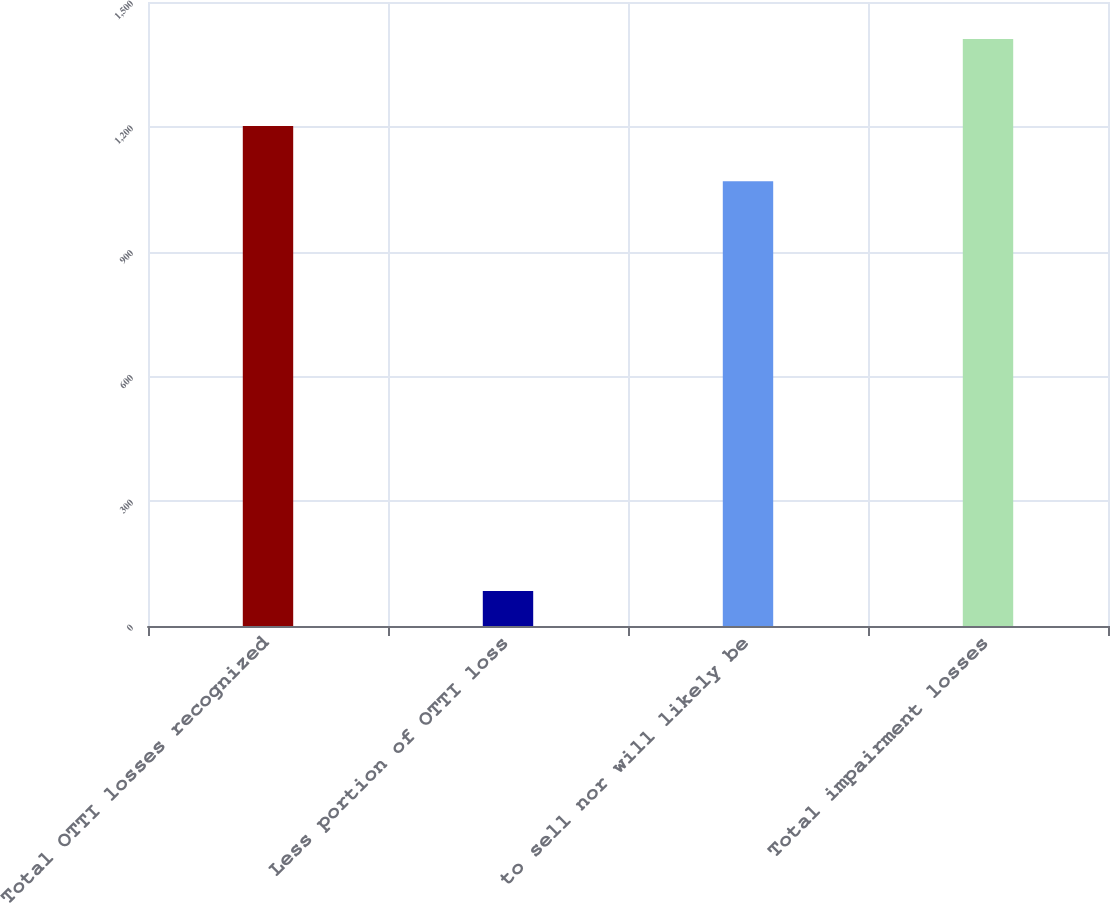Convert chart to OTSL. <chart><loc_0><loc_0><loc_500><loc_500><bar_chart><fcel>Total OTTI losses recognized<fcel>Less portion of OTTI loss<fcel>to sell nor will likely be<fcel>Total impairment losses<nl><fcel>1201.7<fcel>84<fcel>1069<fcel>1411<nl></chart> 